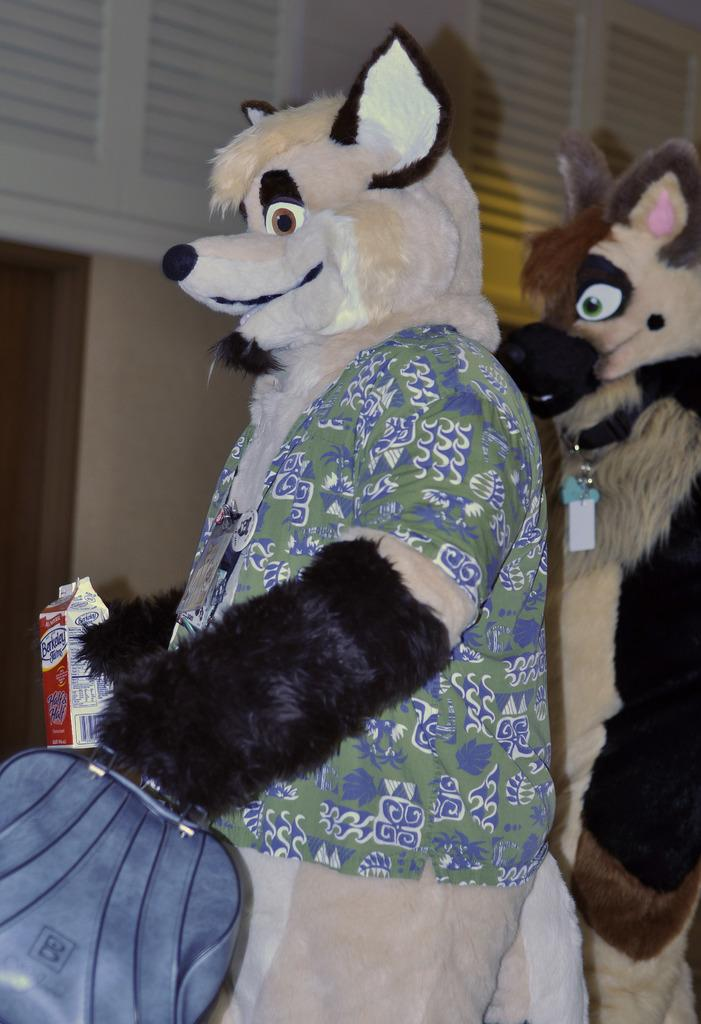What type of characters are present in the image? There are mascots in the image. What is one of the mascots holding? A mascot is holding a bag. What is the other mascot holding? A mascot is holding an object. What can be seen in the background of the image? There is a well in the background of the image. What is located at the top of the image? There is an object at the top of the image. What type of plot is visible in the image? There is no plot visible in the image; it features mascots and a well in the background. How many birds can be seen in the image? There are no birds present in the image. 